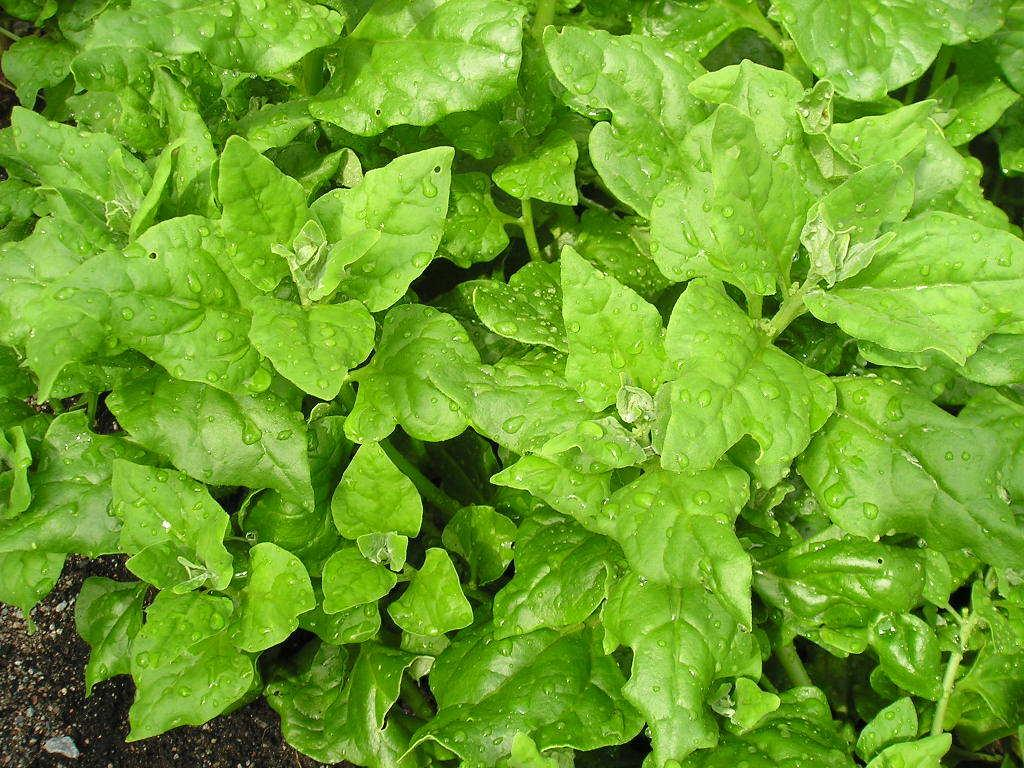What type of living organisms can be seen in the image? Plants can be seen in the image. Where are the plants located? The plants are on the ground. What can be observed on the leaves of the plants? There are water droplets on the leaves of the plants. What type of star can be seen shining brightly in the image? There is no star present in the image; it features plants on the ground with water droplets on their leaves. What type of stem is visible in the image? The provided facts do not mention any stems in the image, only plants and water droplets on their leaves. 